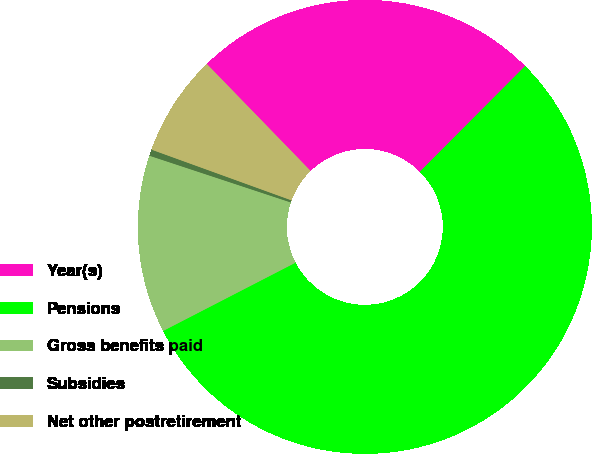Convert chart to OTSL. <chart><loc_0><loc_0><loc_500><loc_500><pie_chart><fcel>Year(s)<fcel>Pensions<fcel>Gross benefits paid<fcel>Subsidies<fcel>Net other postretirement<nl><fcel>24.73%<fcel>54.95%<fcel>12.66%<fcel>0.45%<fcel>7.21%<nl></chart> 